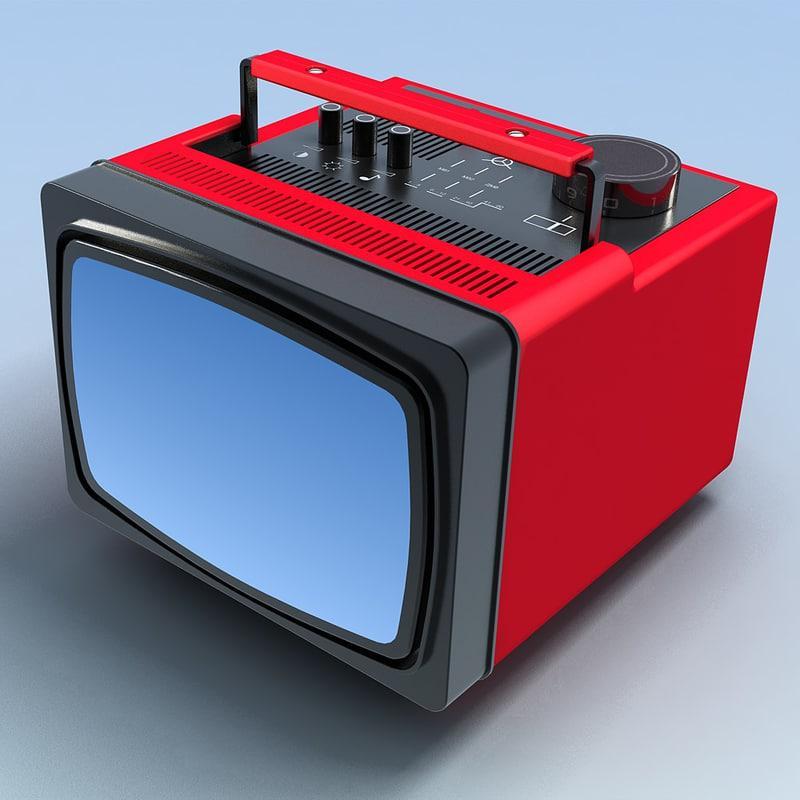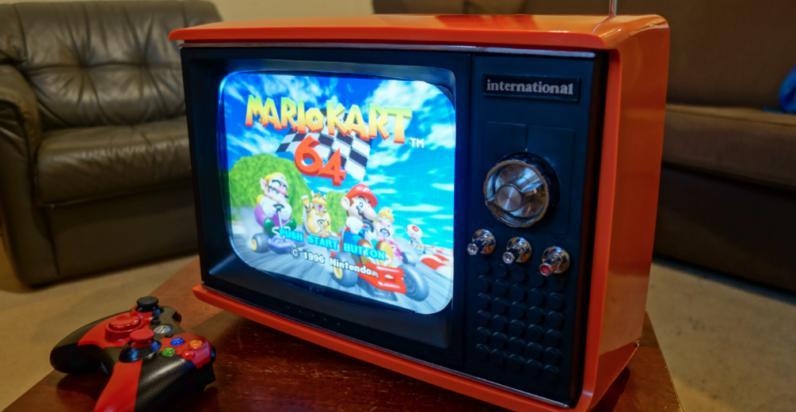The first image is the image on the left, the second image is the image on the right. Evaluate the accuracy of this statement regarding the images: "One TV has a handle projecting from the top, and the other TV has an orange case and sits on a table by a game controller.". Is it true? Answer yes or no. Yes. The first image is the image on the left, the second image is the image on the right. For the images shown, is this caption "One of the images shows a video game controller near a television." true? Answer yes or no. Yes. 